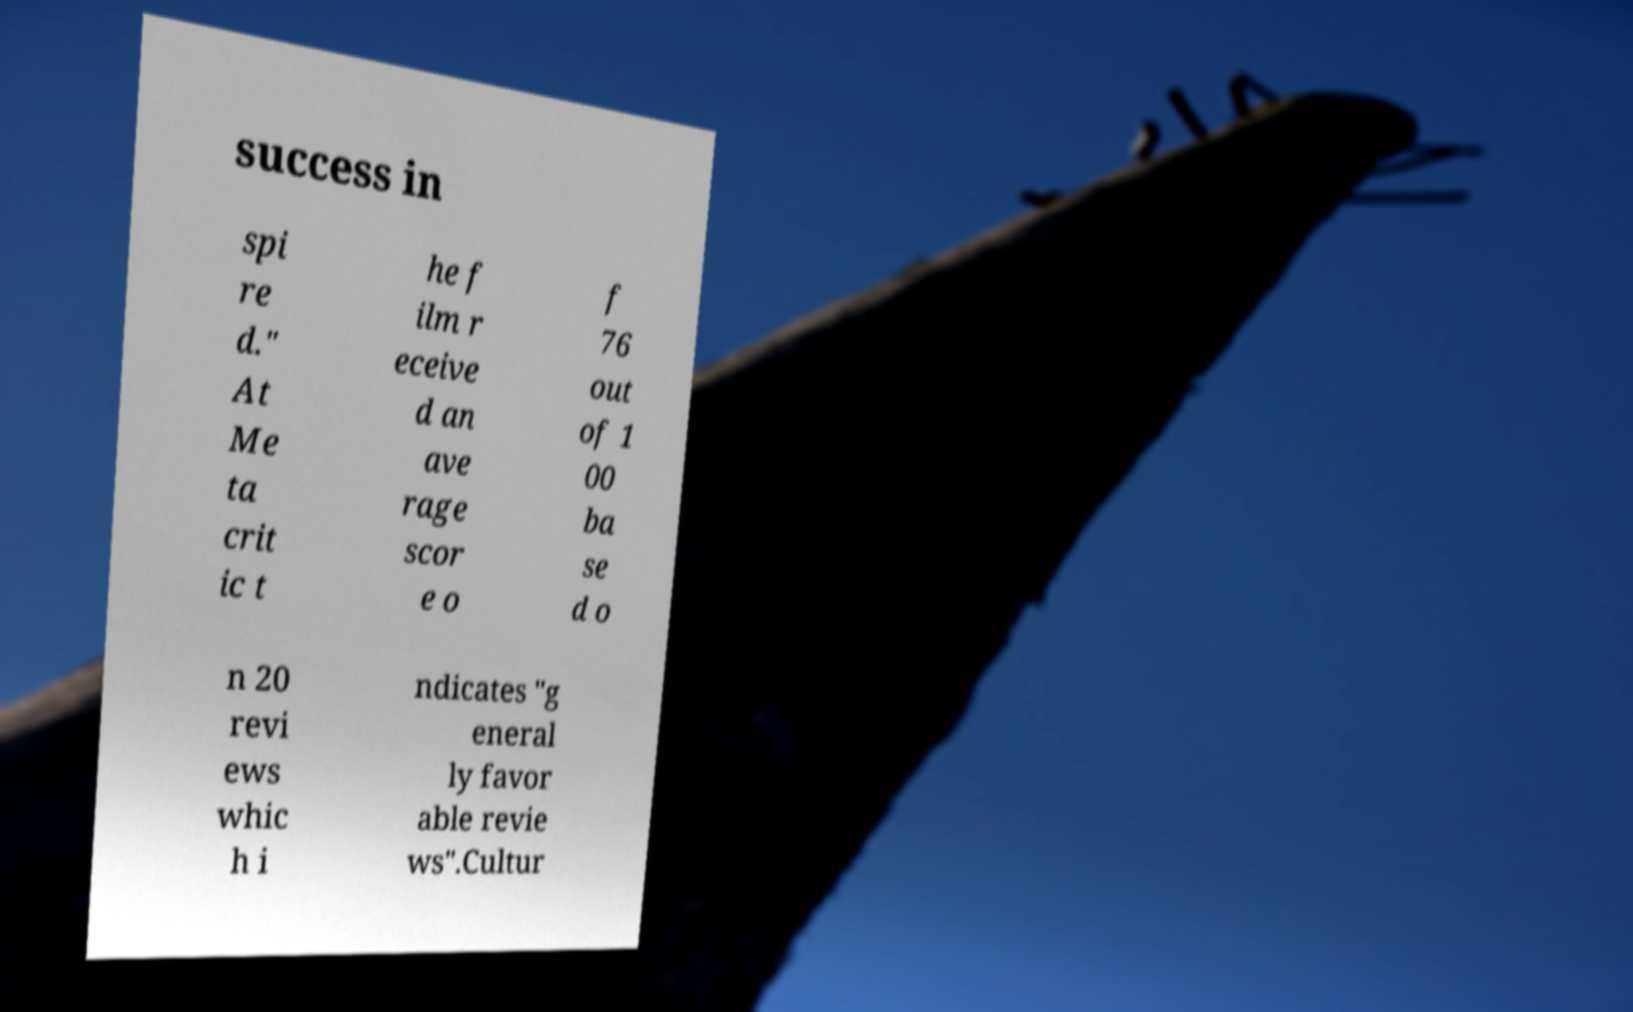What messages or text are displayed in this image? I need them in a readable, typed format. success in spi re d." At Me ta crit ic t he f ilm r eceive d an ave rage scor e o f 76 out of 1 00 ba se d o n 20 revi ews whic h i ndicates "g eneral ly favor able revie ws".Cultur 